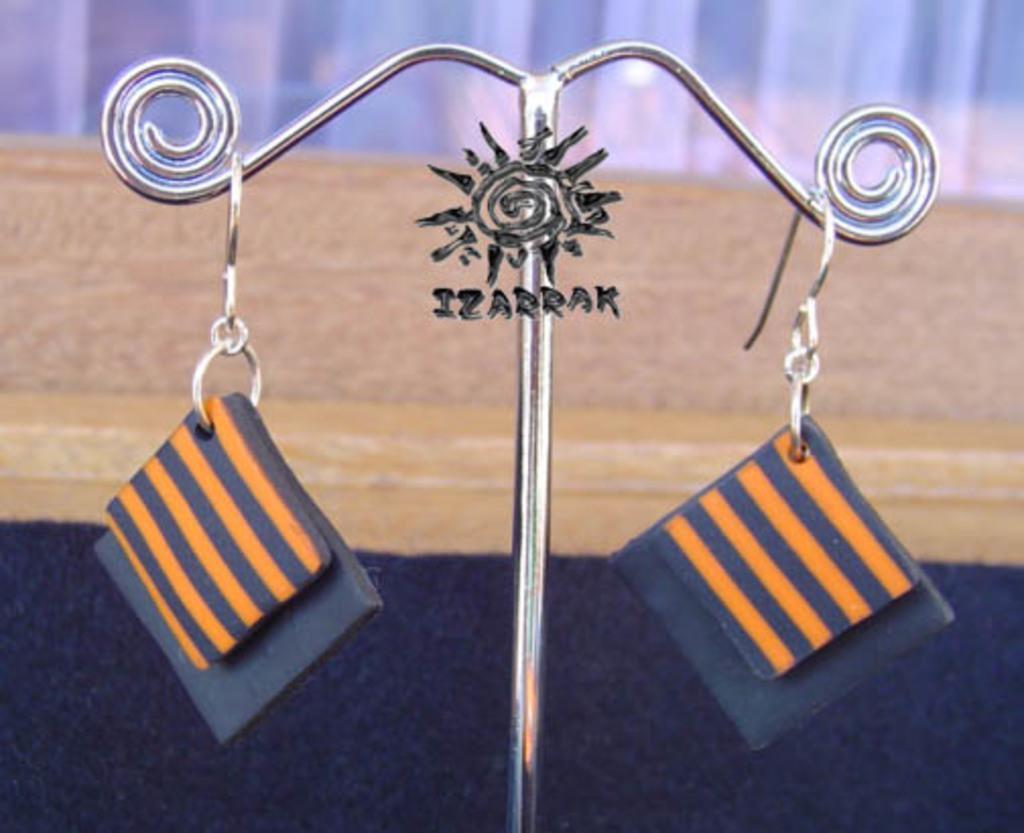Could you give a brief overview of what you see in this image? In the picture we can see an earring stand with an earring which are blue in color square shape and some orange lines on it and in the background we can see a wooden plank. 